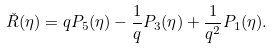<formula> <loc_0><loc_0><loc_500><loc_500>\check { R } ( \eta ) = q P _ { 5 } ( \eta ) - \frac { 1 } { q } P _ { 3 } ( \eta ) + \frac { 1 } { q ^ { 2 } } P _ { 1 } ( \eta ) .</formula> 